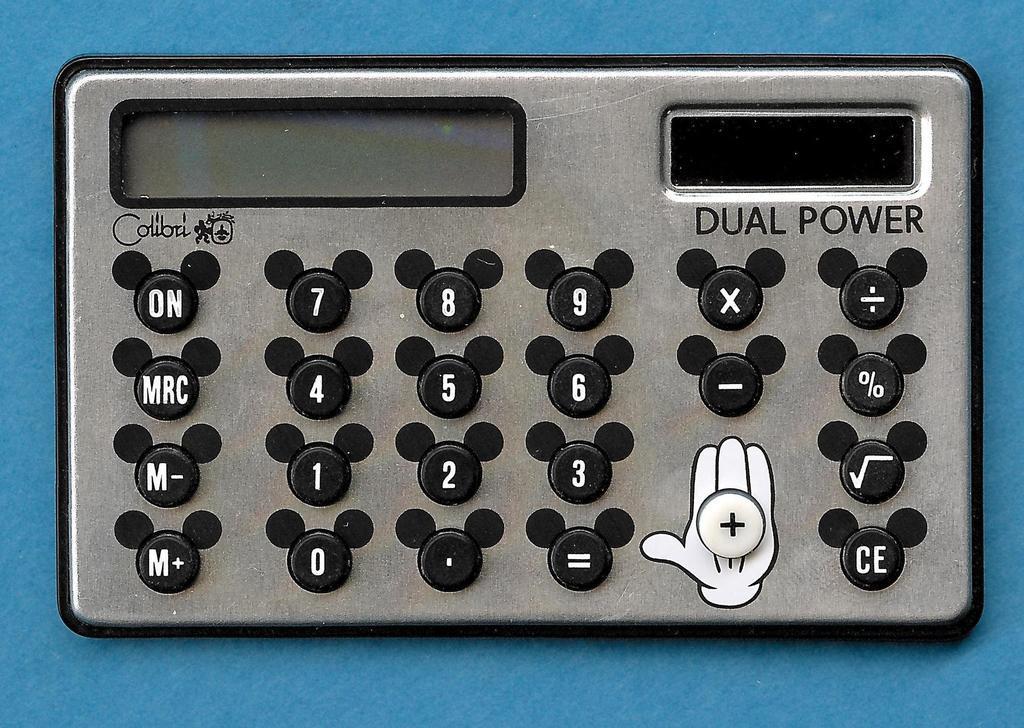Describe this image in one or two sentences. In this image we can see an electronic gadget. 